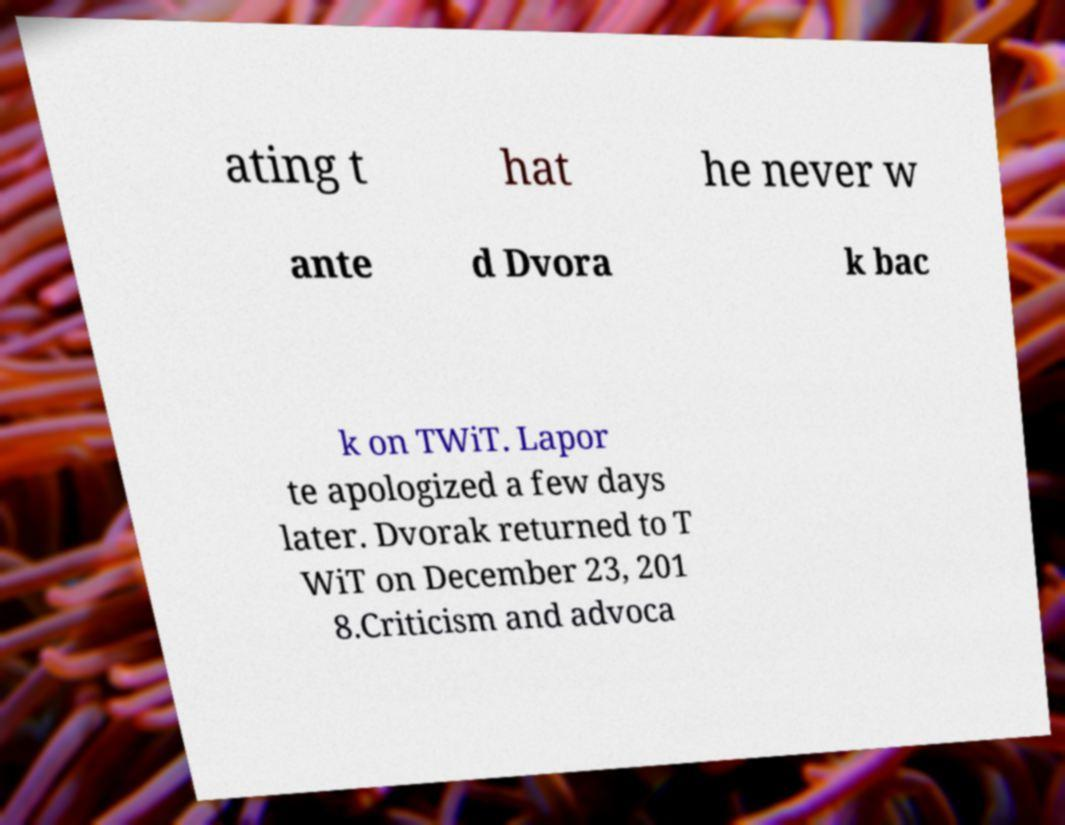Could you assist in decoding the text presented in this image and type it out clearly? ating t hat he never w ante d Dvora k bac k on TWiT. Lapor te apologized a few days later. Dvorak returned to T WiT on December 23, 201 8.Criticism and advoca 